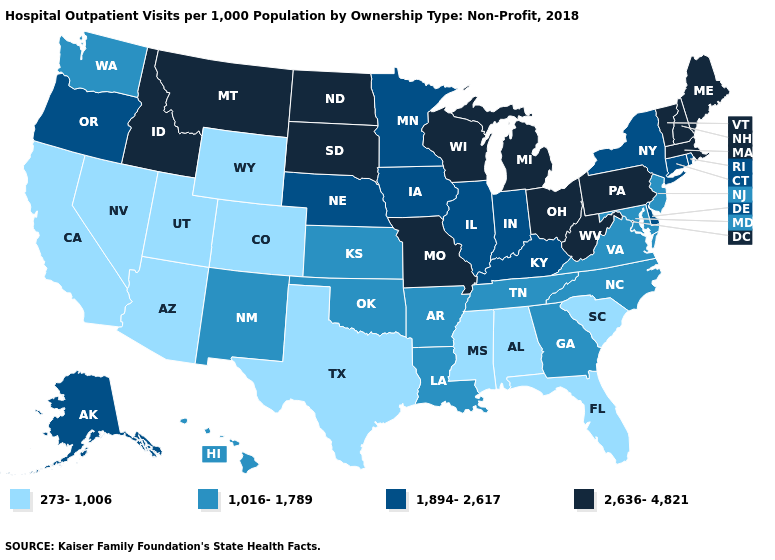What is the value of Mississippi?
Write a very short answer. 273-1,006. What is the highest value in states that border Nebraska?
Keep it brief. 2,636-4,821. What is the value of Missouri?
Write a very short answer. 2,636-4,821. Name the states that have a value in the range 2,636-4,821?
Write a very short answer. Idaho, Maine, Massachusetts, Michigan, Missouri, Montana, New Hampshire, North Dakota, Ohio, Pennsylvania, South Dakota, Vermont, West Virginia, Wisconsin. Among the states that border Pennsylvania , which have the highest value?
Quick response, please. Ohio, West Virginia. Which states have the lowest value in the West?
Quick response, please. Arizona, California, Colorado, Nevada, Utah, Wyoming. What is the value of Minnesota?
Give a very brief answer. 1,894-2,617. Name the states that have a value in the range 273-1,006?
Be succinct. Alabama, Arizona, California, Colorado, Florida, Mississippi, Nevada, South Carolina, Texas, Utah, Wyoming. Does Illinois have the lowest value in the USA?
Give a very brief answer. No. Name the states that have a value in the range 273-1,006?
Answer briefly. Alabama, Arizona, California, Colorado, Florida, Mississippi, Nevada, South Carolina, Texas, Utah, Wyoming. Name the states that have a value in the range 1,894-2,617?
Be succinct. Alaska, Connecticut, Delaware, Illinois, Indiana, Iowa, Kentucky, Minnesota, Nebraska, New York, Oregon, Rhode Island. Among the states that border Oklahoma , does New Mexico have the lowest value?
Write a very short answer. No. Name the states that have a value in the range 1,016-1,789?
Concise answer only. Arkansas, Georgia, Hawaii, Kansas, Louisiana, Maryland, New Jersey, New Mexico, North Carolina, Oklahoma, Tennessee, Virginia, Washington. Among the states that border Nebraska , does Colorado have the lowest value?
Be succinct. Yes. Among the states that border Florida , does Alabama have the highest value?
Answer briefly. No. 